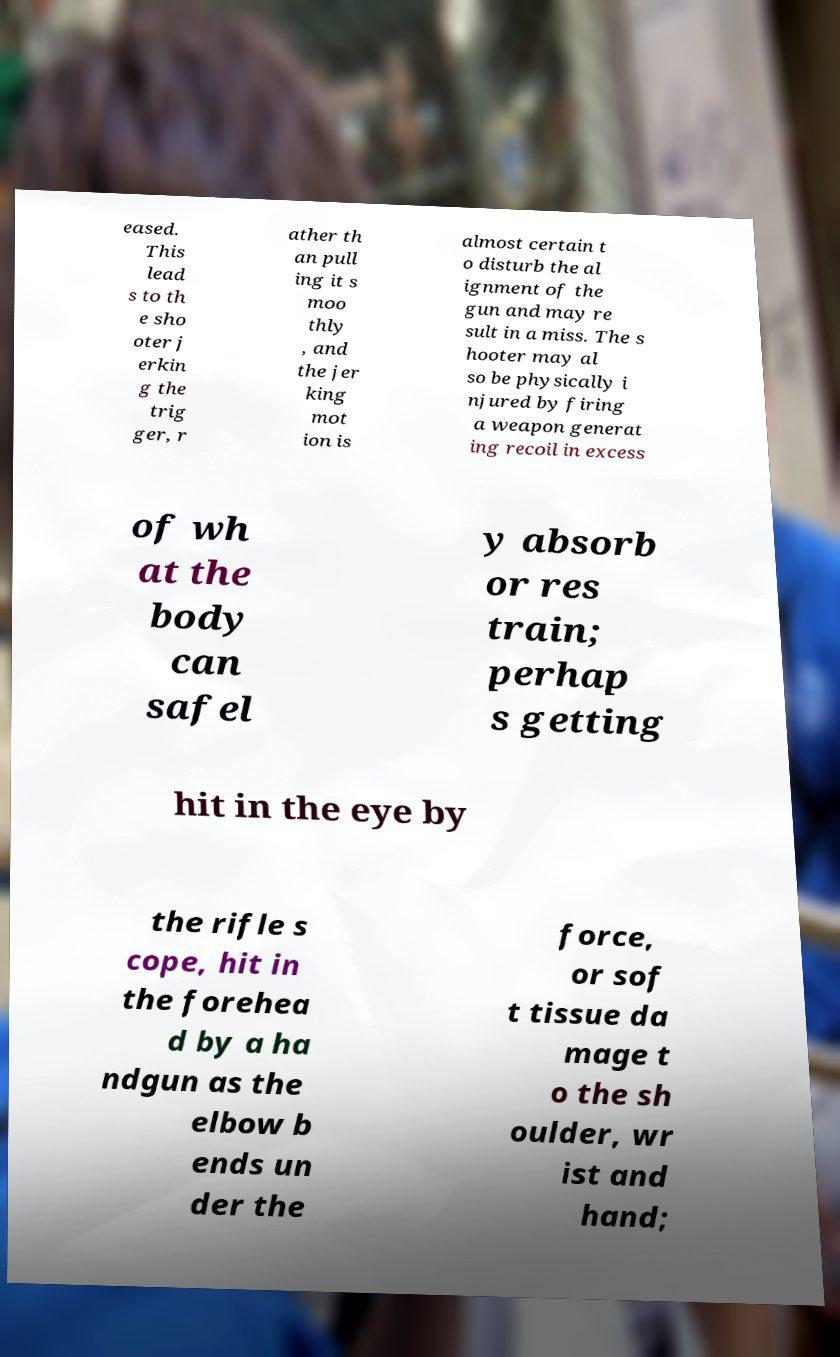For documentation purposes, I need the text within this image transcribed. Could you provide that? eased. This lead s to th e sho oter j erkin g the trig ger, r ather th an pull ing it s moo thly , and the jer king mot ion is almost certain t o disturb the al ignment of the gun and may re sult in a miss. The s hooter may al so be physically i njured by firing a weapon generat ing recoil in excess of wh at the body can safel y absorb or res train; perhap s getting hit in the eye by the rifle s cope, hit in the forehea d by a ha ndgun as the elbow b ends un der the force, or sof t tissue da mage t o the sh oulder, wr ist and hand; 